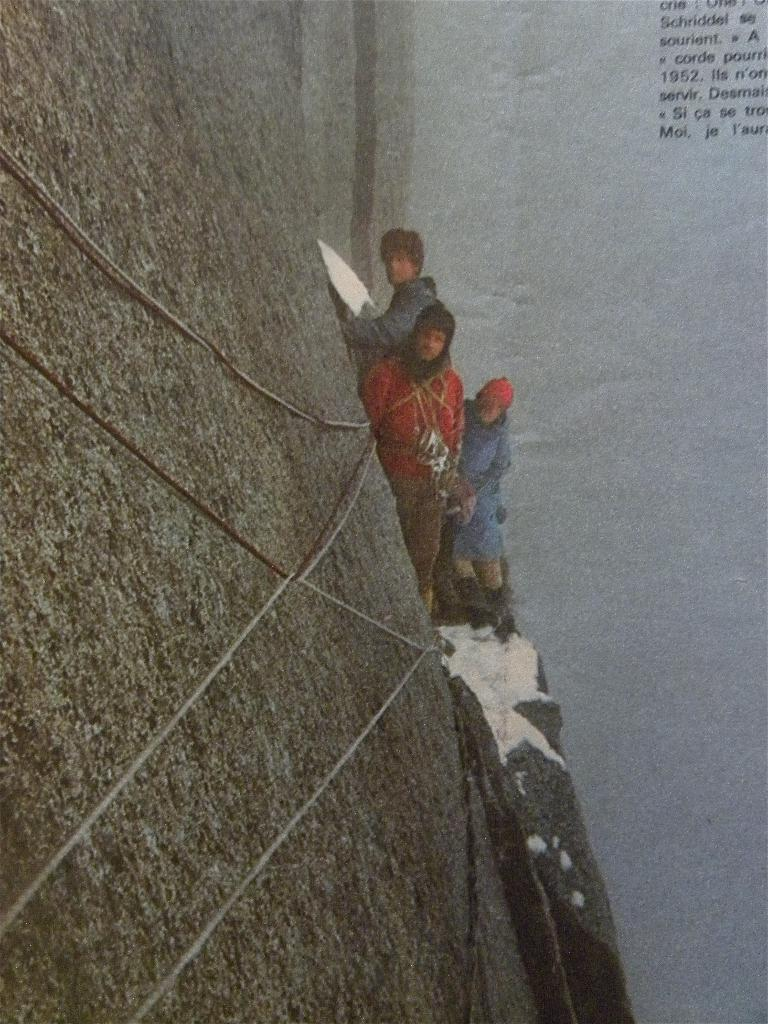How many people are present in the image? There are three people in the image. What can be observed about the clothing of the people in the image? The people are wearing different color dresses. Can you describe any accessories worn by the people in the image? One person is wearing a cap. What objects can be seen on the left side of the image? There is a rope and rock on the left side of the image. What is visible on the right side of the image? There is text visible on the right side of the image. What type of pipe can be seen in the image? There is no pipe present in the image. How many clams are visible in the image? There are no clams present in the image. 